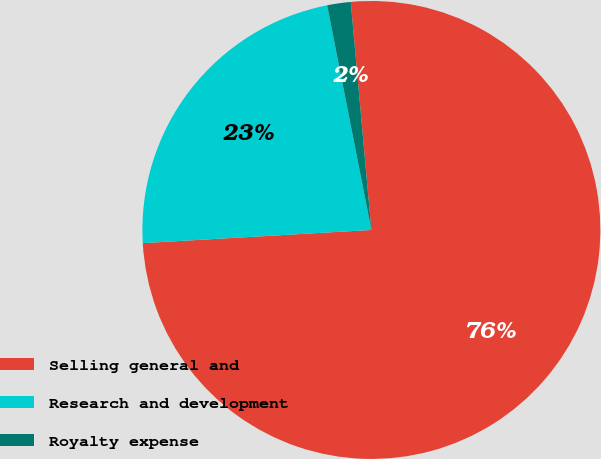Convert chart. <chart><loc_0><loc_0><loc_500><loc_500><pie_chart><fcel>Selling general and<fcel>Research and development<fcel>Royalty expense<nl><fcel>75.52%<fcel>22.82%<fcel>1.66%<nl></chart> 